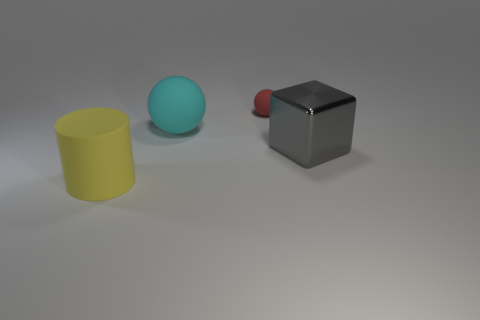There is a big matte thing that is behind the large yellow object; does it have the same color as the small matte thing?
Offer a very short reply. No. What number of things are either large shiny things or small red matte spheres?
Provide a succinct answer. 2. There is a large matte thing that is behind the matte cylinder; what color is it?
Keep it short and to the point. Cyan. Is the number of big rubber things on the left side of the yellow cylinder less than the number of yellow blocks?
Your answer should be very brief. No. Are there any other things that have the same size as the cyan object?
Ensure brevity in your answer.  Yes. Does the yellow thing have the same material as the small ball?
Your answer should be very brief. Yes. What number of things are either large matte objects in front of the gray metallic block or rubber objects that are behind the big cyan rubber object?
Give a very brief answer. 2. Are there any cyan rubber things that have the same size as the yellow matte object?
Your answer should be very brief. Yes. What is the color of the other thing that is the same shape as the large cyan rubber thing?
Keep it short and to the point. Red. There is a large thing that is to the right of the cyan thing; is there a sphere that is in front of it?
Provide a succinct answer. No. 